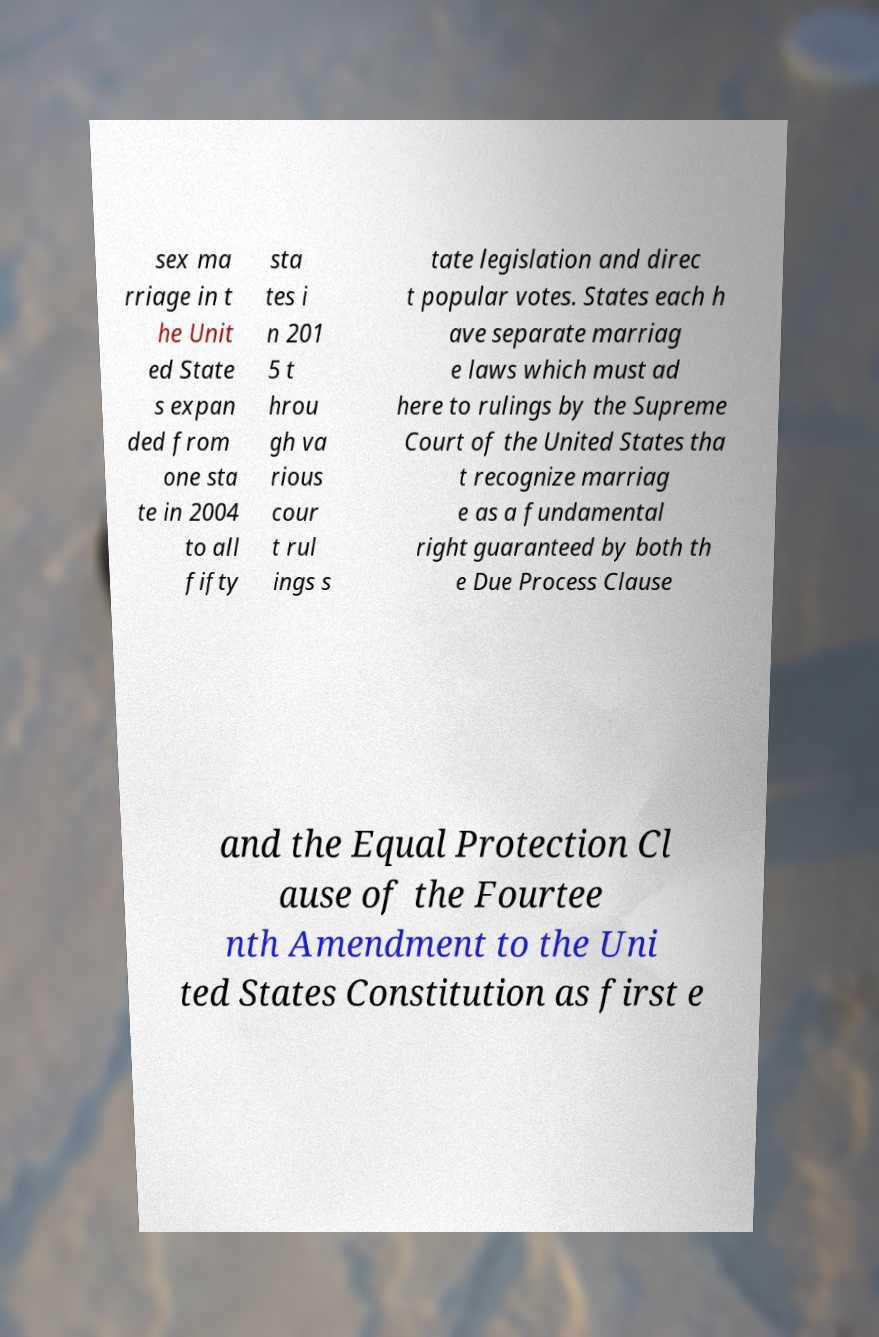What messages or text are displayed in this image? I need them in a readable, typed format. sex ma rriage in t he Unit ed State s expan ded from one sta te in 2004 to all fifty sta tes i n 201 5 t hrou gh va rious cour t rul ings s tate legislation and direc t popular votes. States each h ave separate marriag e laws which must ad here to rulings by the Supreme Court of the United States tha t recognize marriag e as a fundamental right guaranteed by both th e Due Process Clause and the Equal Protection Cl ause of the Fourtee nth Amendment to the Uni ted States Constitution as first e 